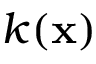<formula> <loc_0><loc_0><loc_500><loc_500>k ( x )</formula> 